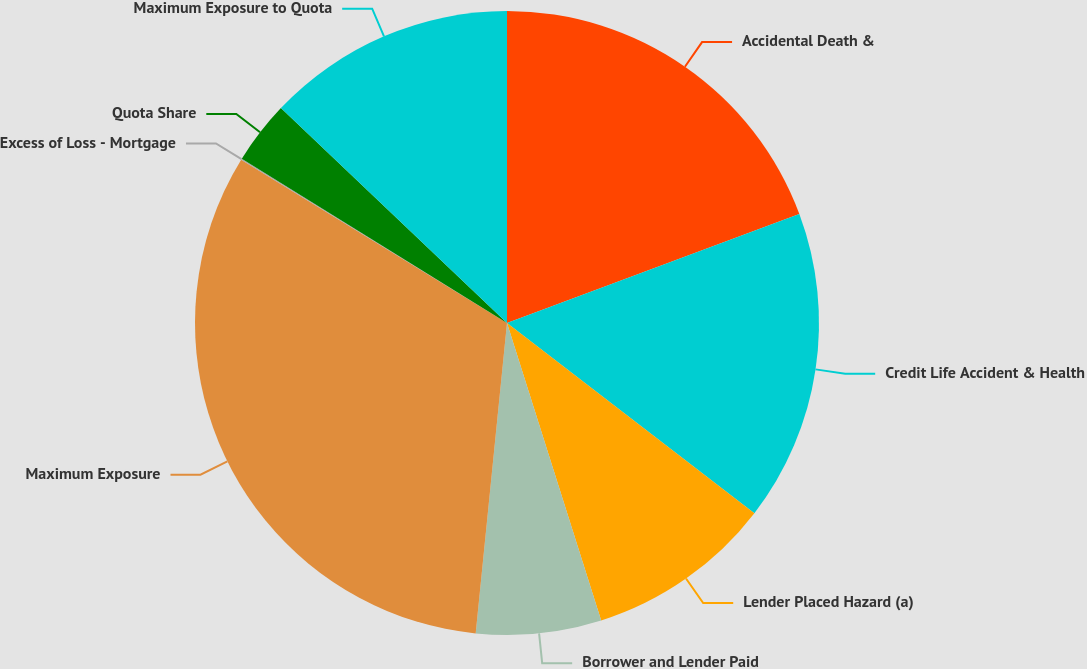Convert chart to OTSL. <chart><loc_0><loc_0><loc_500><loc_500><pie_chart><fcel>Accidental Death &<fcel>Credit Life Accident & Health<fcel>Lender Placed Hazard (a)<fcel>Borrower and Lender Paid<fcel>Maximum Exposure<fcel>Excess of Loss - Mortgage<fcel>Quota Share<fcel>Maximum Exposure to Quota<nl><fcel>19.32%<fcel>16.11%<fcel>9.69%<fcel>6.48%<fcel>32.17%<fcel>0.06%<fcel>3.27%<fcel>12.9%<nl></chart> 